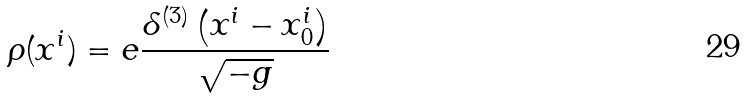Convert formula to latex. <formula><loc_0><loc_0><loc_500><loc_500>\rho ( x ^ { i } ) = e \frac { \delta ^ { ( 3 ) } \left ( x ^ { i } - x _ { 0 } ^ { i } \right ) } { \sqrt { - g } }</formula> 